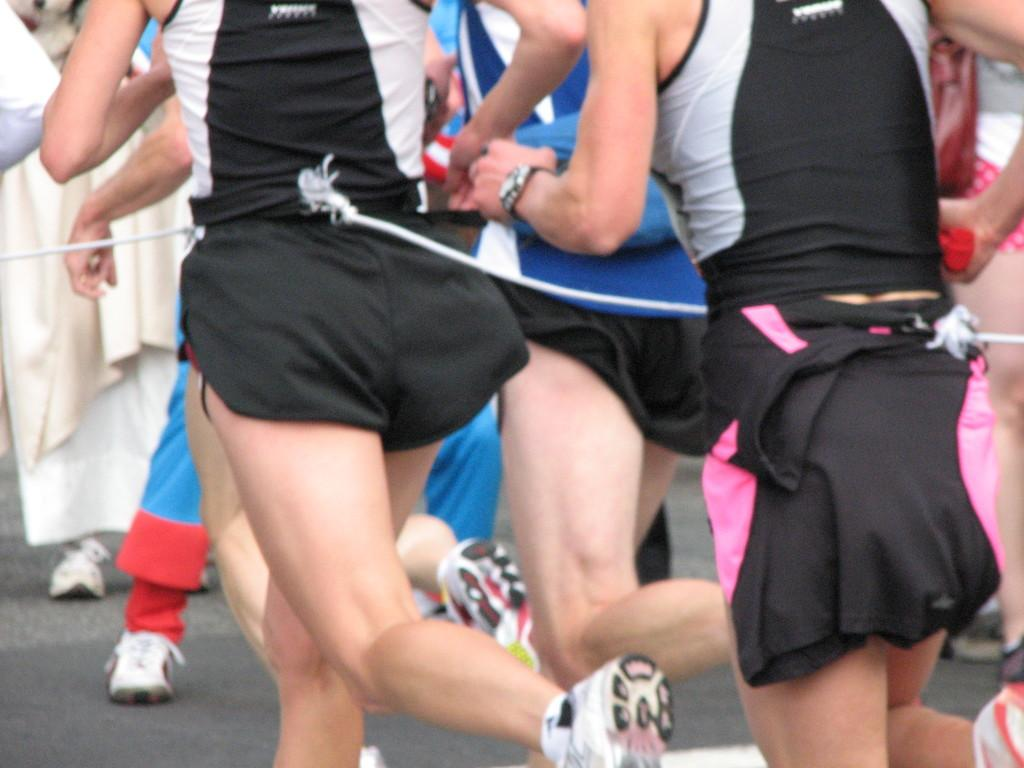What body parts can be seen in the image? Hands and legs are visible in the image. What type of pathway is present in the image? There is a road in the image. What object can be seen that is typically used for tying or pulling? There is a rope in the image. How many deer are visible in the image? There are no deer present in the image. What type of metal is used to create the brush in the image? There is no brush present in the image. 